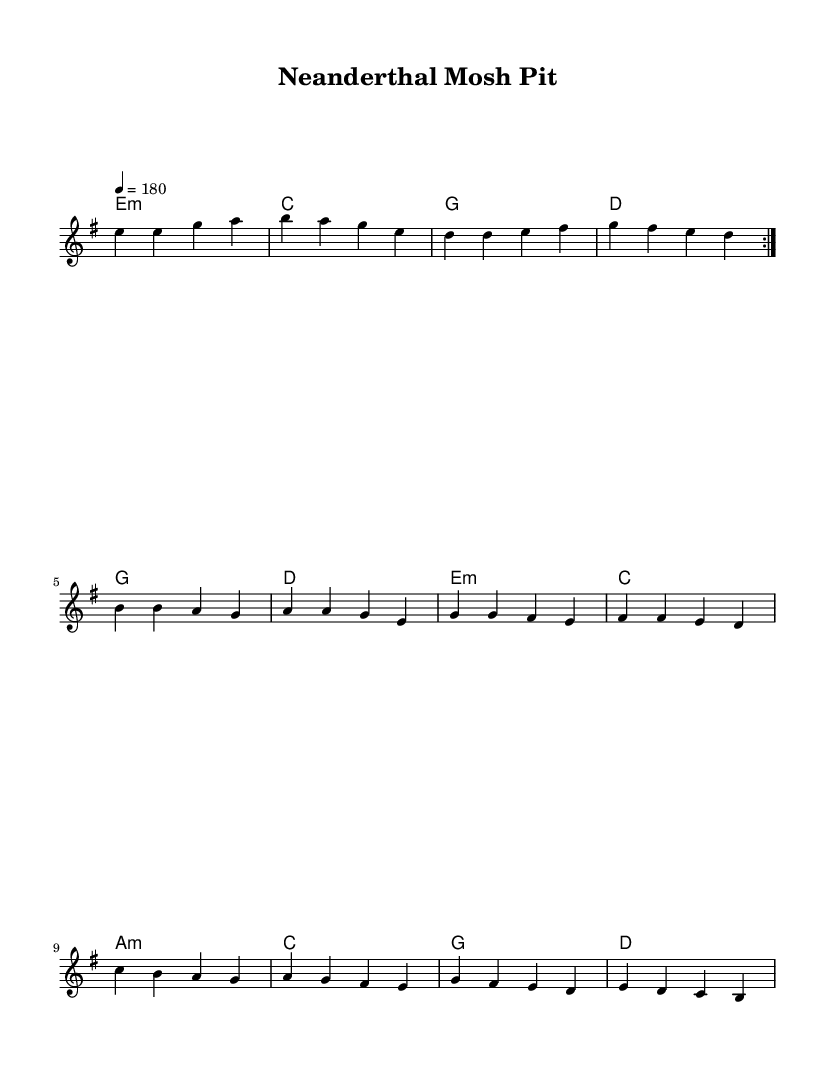What is the key signature of this music? The key signature is indicated by the symbol at the beginning of the staff. In this case, it displays one sharp, which corresponds to E minor.
Answer: E minor What is the time signature of this music? The time signature is found at the beginning of the music staff. It shows a "4/4" symbol, indicating there are four beats per measure and the quarter note gets one beat.
Answer: 4/4 What is the tempo marking for this piece? The tempo marking appears above the staff, indicating how fast the piece should be played. In this case, it reads "4 = 180," meaning you should play at 180 beats per minute, with each quarter note receiving one beat.
Answer: 180 How many verses are there before the chorus? The verses are structured in a repeated section indicated by the volta markings (repeat signs) before the chorus. Since there’s a "repeat volta 2" instruction, it signifies that the verse is played two times before moving to the chorus.
Answer: 2 What type of heterophonic structure is represented in this music? The presence of guitars playing distinct chords while the vocal melody carries the lyrics represents the heterophonic texture typical in punk music. Each part proceeds independently while complementing each other, illustrating a punk characteristic of celebrating accessibility and diversity.
Answer: Heterophonic Which hominid species is mentioned in the bridge section? The bridge contains lyrics that specifically mention "Homo erectus" and "Homo habilis," among others. These species are highlighted to emphasize the diversity of Pleistocene hominids celebrated in the song's context.
Answer: Homo erectus, Homo habilis What is the overall theme of the lyrics? The lyrics convey themes of diversity and strength among Pleistocene hominids, celebrating their existence and evolutionary history. This is central to the song's message, embodying both educational and artistic expressions typical of punk music.
Answer: Diversity and strength 